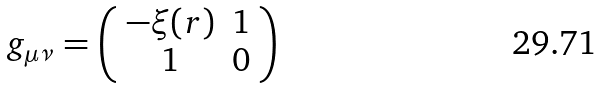<formula> <loc_0><loc_0><loc_500><loc_500>g _ { \mu \nu } = \left ( \begin{array} { c c } - \xi ( r ) & 1 \\ 1 & 0 \end{array} \right )</formula> 